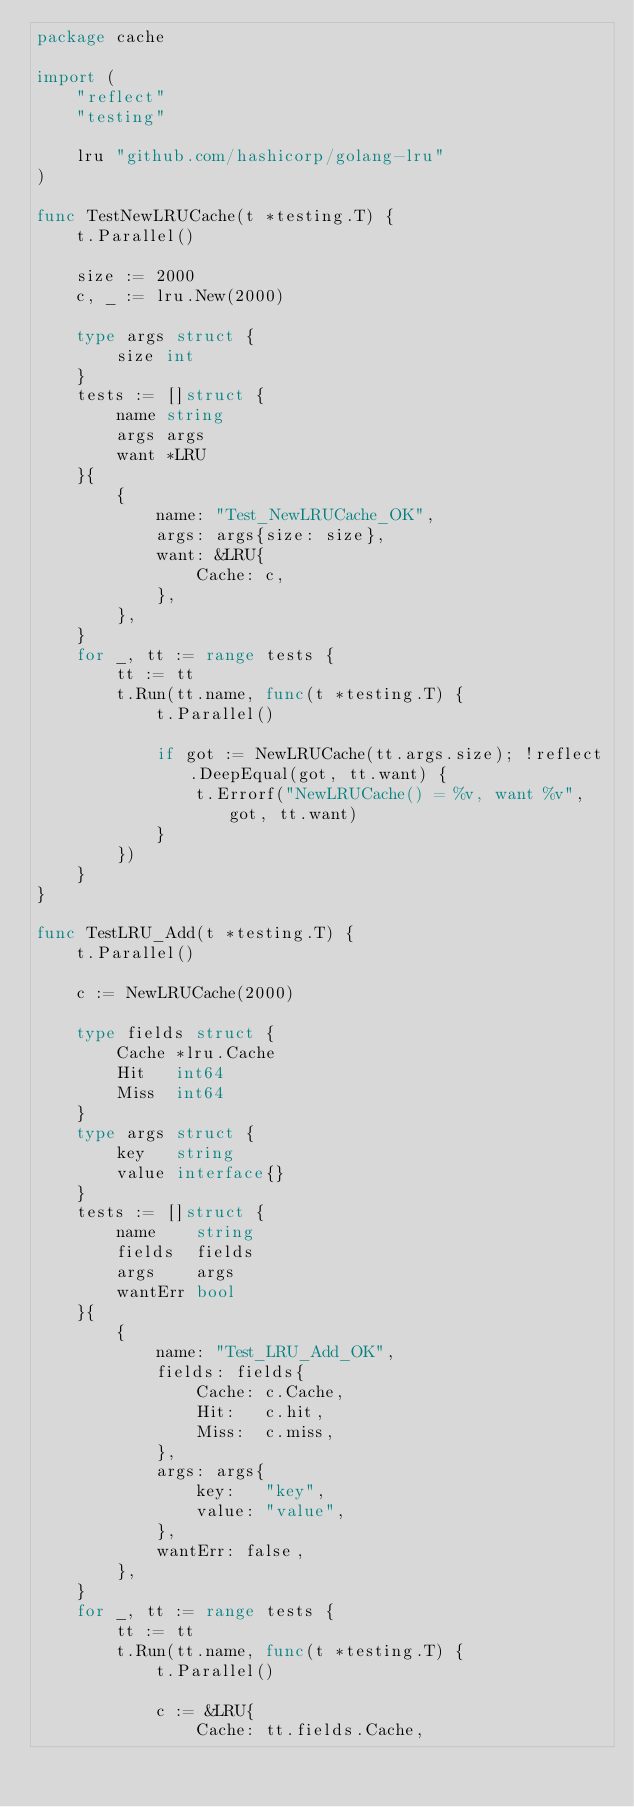Convert code to text. <code><loc_0><loc_0><loc_500><loc_500><_Go_>package cache

import (
	"reflect"
	"testing"

	lru "github.com/hashicorp/golang-lru"
)

func TestNewLRUCache(t *testing.T) {
	t.Parallel()

	size := 2000
	c, _ := lru.New(2000)

	type args struct {
		size int
	}
	tests := []struct {
		name string
		args args
		want *LRU
	}{
		{
			name: "Test_NewLRUCache_OK",
			args: args{size: size},
			want: &LRU{
				Cache: c,
			},
		},
	}
	for _, tt := range tests {
		tt := tt
		t.Run(tt.name, func(t *testing.T) {
			t.Parallel()

			if got := NewLRUCache(tt.args.size); !reflect.DeepEqual(got, tt.want) {
				t.Errorf("NewLRUCache() = %v, want %v", got, tt.want)
			}
		})
	}
}

func TestLRU_Add(t *testing.T) {
	t.Parallel()

	c := NewLRUCache(2000)

	type fields struct {
		Cache *lru.Cache
		Hit   int64
		Miss  int64
	}
	type args struct {
		key   string
		value interface{}
	}
	tests := []struct {
		name    string
		fields  fields
		args    args
		wantErr bool
	}{
		{
			name: "Test_LRU_Add_OK",
			fields: fields{
				Cache: c.Cache,
				Hit:   c.hit,
				Miss:  c.miss,
			},
			args: args{
				key:   "key",
				value: "value",
			},
			wantErr: false,
		},
	}
	for _, tt := range tests {
		tt := tt
		t.Run(tt.name, func(t *testing.T) {
			t.Parallel()

			c := &LRU{
				Cache: tt.fields.Cache,</code> 